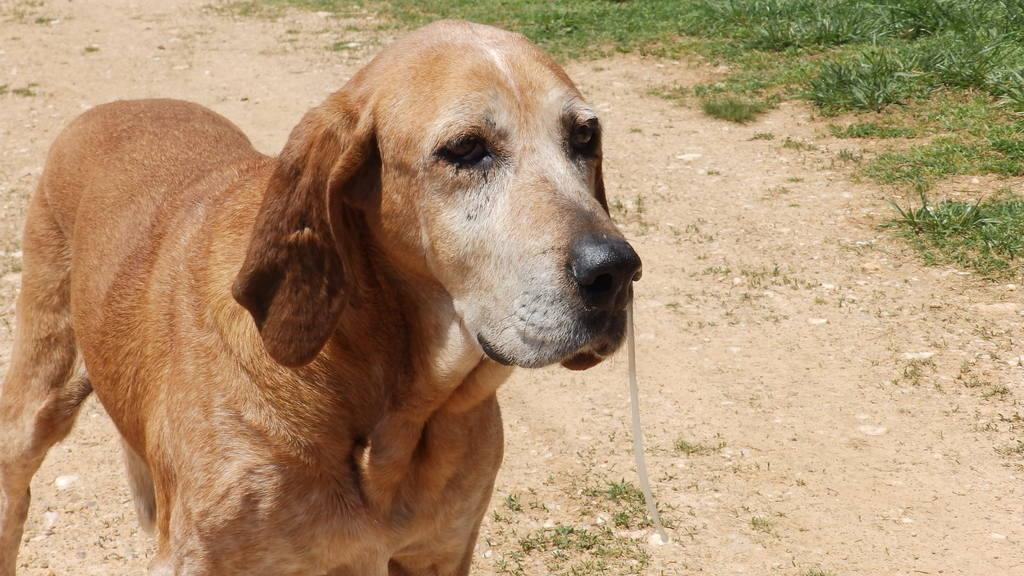Could you give a brief overview of what you see in this image? This picture is clicked outside. On the left we can see a dog standing on the ground. On the right we can see the green grass. 